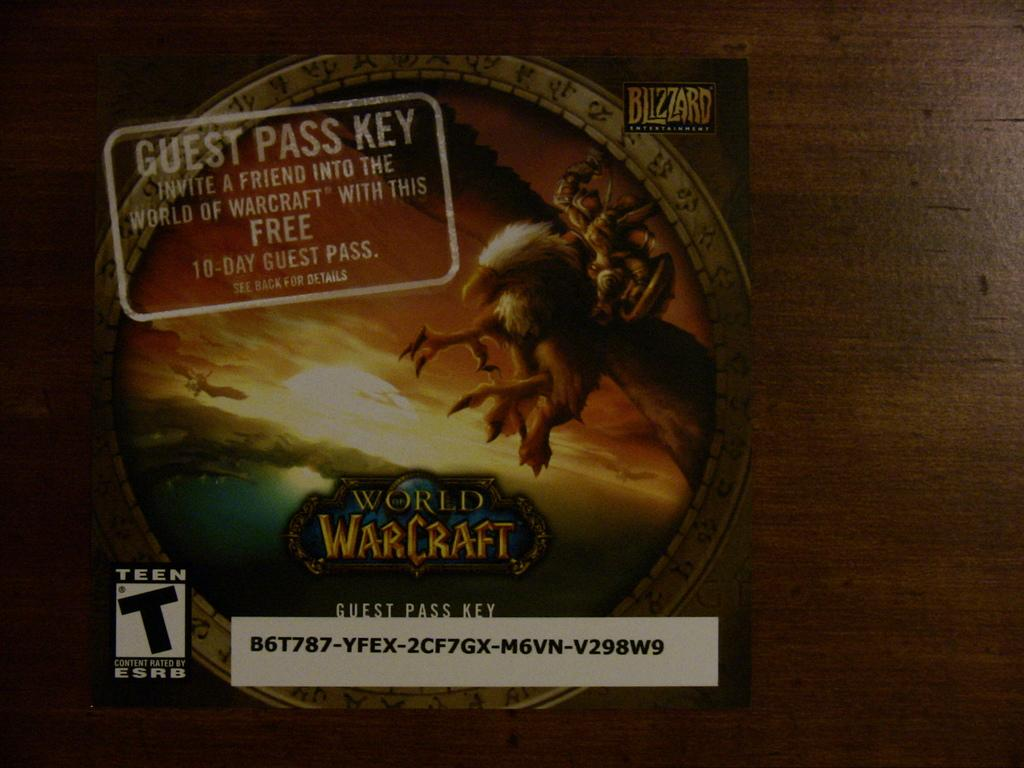<image>
Create a compact narrative representing the image presented. A guest day pass key for world warcraft. 